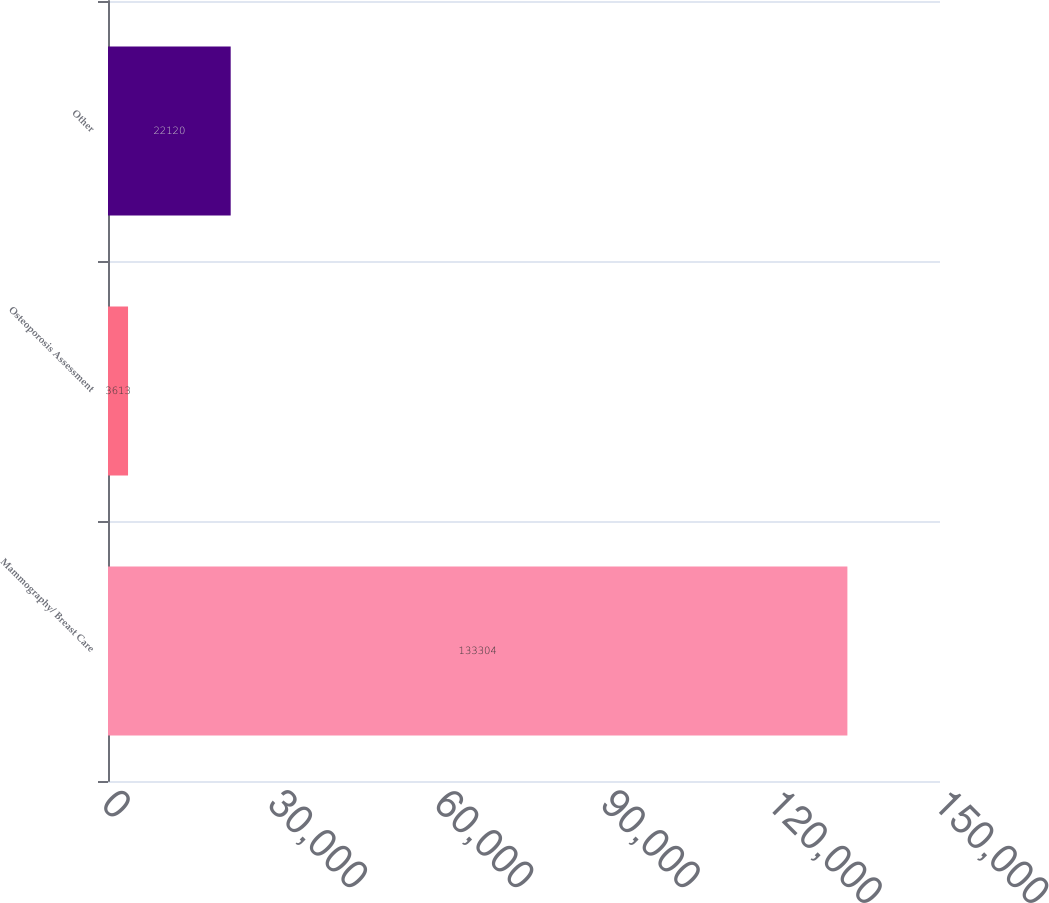Convert chart to OTSL. <chart><loc_0><loc_0><loc_500><loc_500><bar_chart><fcel>Mammography/ Breast Care<fcel>Osteoporosis Assessment<fcel>Other<nl><fcel>133304<fcel>3613<fcel>22120<nl></chart> 